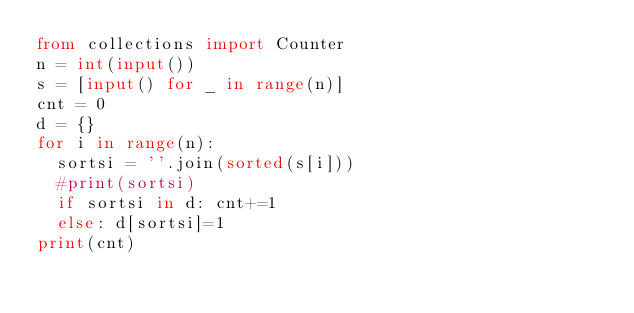<code> <loc_0><loc_0><loc_500><loc_500><_Python_>from collections import Counter
n = int(input())
s = [input() for _ in range(n)]
cnt = 0
d = {}
for i in range(n):
  sortsi = ''.join(sorted(s[i]))
  #print(sortsi)
  if sortsi in d: cnt+=1
  else: d[sortsi]=1
print(cnt)</code> 